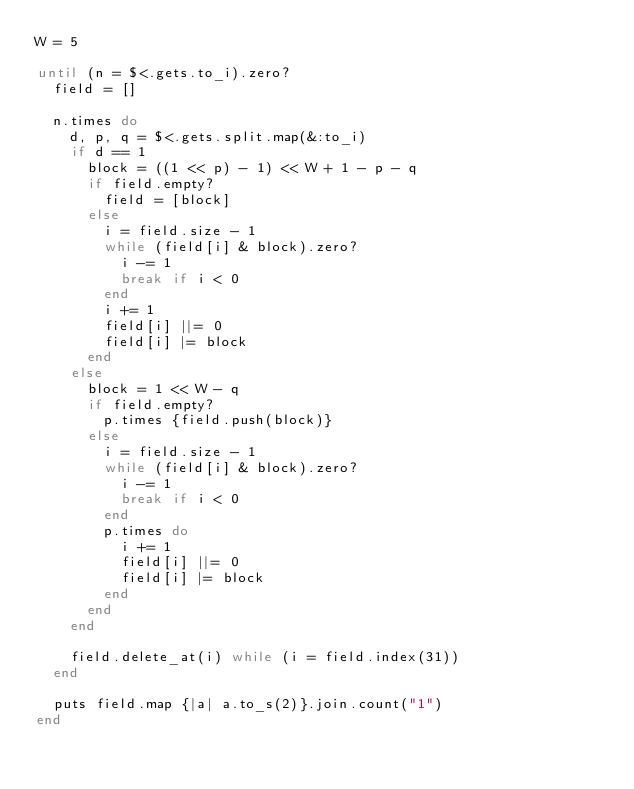<code> <loc_0><loc_0><loc_500><loc_500><_Ruby_>W = 5

until (n = $<.gets.to_i).zero?
  field = []
  
  n.times do
    d, p, q = $<.gets.split.map(&:to_i)
    if d == 1
      block = ((1 << p) - 1) << W + 1 - p - q
      if field.empty?
        field = [block]
      else
        i = field.size - 1
        while (field[i] & block).zero?
          i -= 1
          break if i < 0
        end
        i += 1
        field[i] ||= 0
        field[i] |= block
      end
    else
      block = 1 << W - q
      if field.empty?
        p.times {field.push(block)}
      else
        i = field.size - 1
        while (field[i] & block).zero?
          i -= 1
          break if i < 0
        end
        p.times do
          i += 1
          field[i] ||= 0
          field[i] |= block
        end
      end
    end
    
    field.delete_at(i) while (i = field.index(31))
  end
  
  puts field.map {|a| a.to_s(2)}.join.count("1") 
end
</code> 